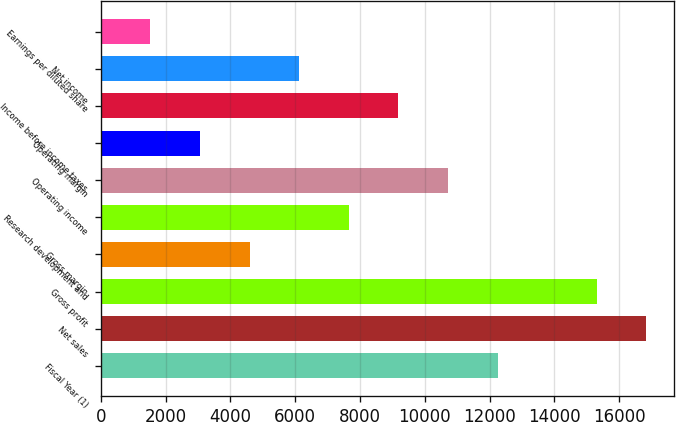Convert chart to OTSL. <chart><loc_0><loc_0><loc_500><loc_500><bar_chart><fcel>Fiscal Year (1)<fcel>Net sales<fcel>Gross profit<fcel>Gross margin<fcel>Research development and<fcel>Operating income<fcel>Operating margin<fcel>Income before income taxes<fcel>Net income<fcel>Earnings per diluted share<nl><fcel>12246.5<fcel>16838.8<fcel>15308<fcel>4592.68<fcel>7654.2<fcel>10715.7<fcel>3061.92<fcel>9184.96<fcel>6123.44<fcel>1531.16<nl></chart> 